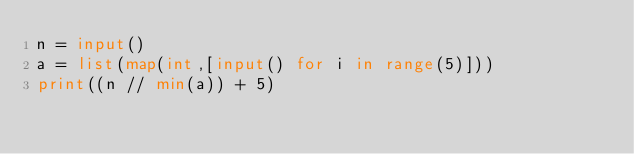<code> <loc_0><loc_0><loc_500><loc_500><_Python_>n = input()
a = list(map(int,[input() for i in range(5)]))
print((n // min(a)) + 5) 
</code> 